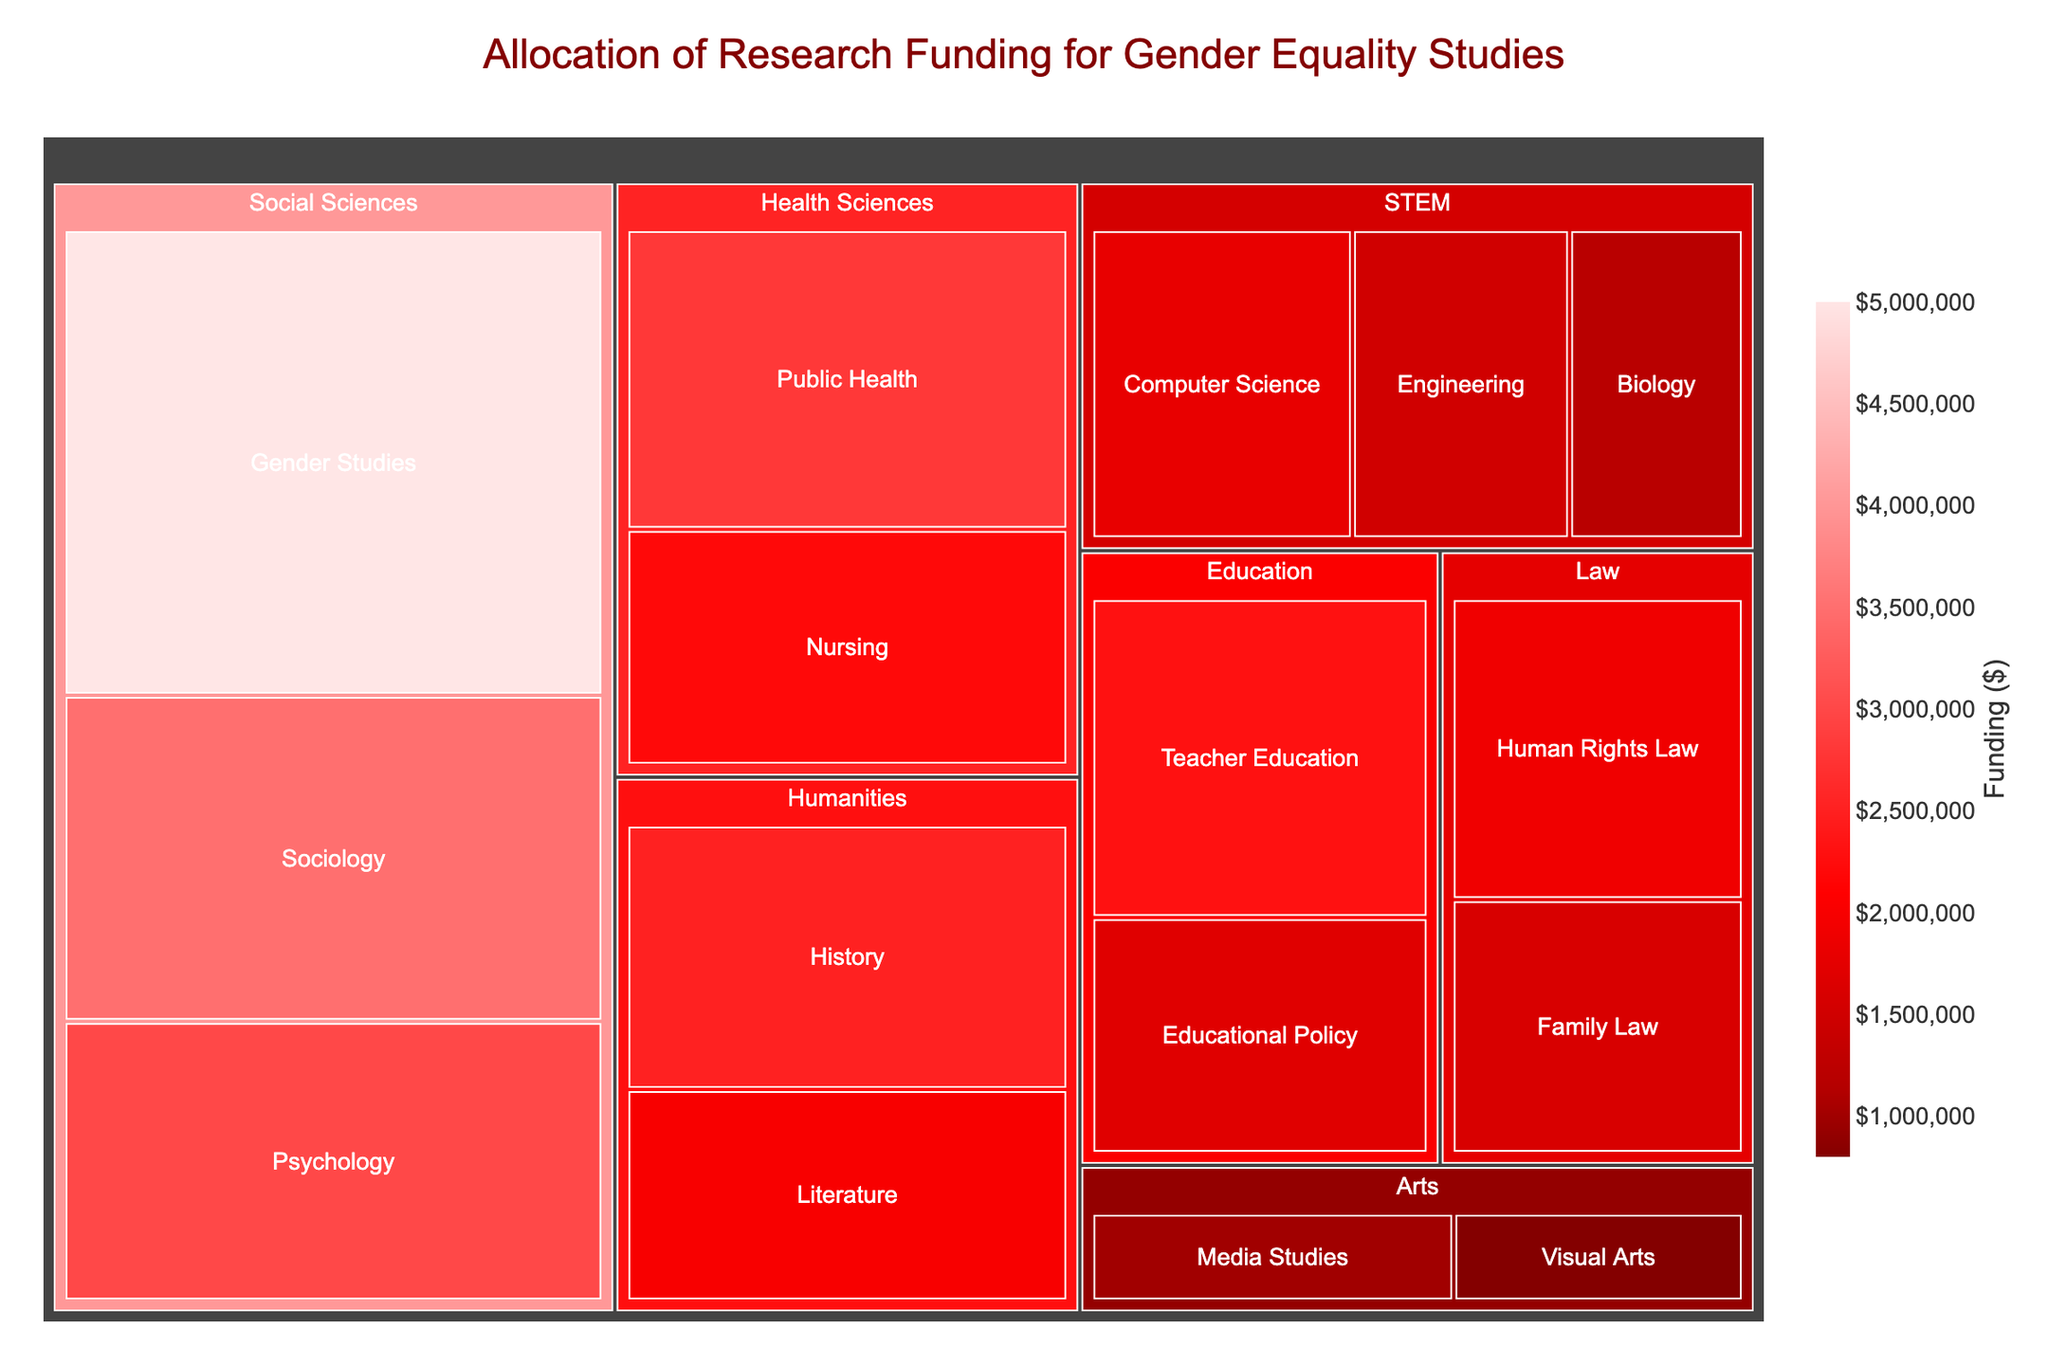what is the total funding for all social sciences subfields? The treemap shows three subfields under social sciences: gender studies, sociology, and psychology. By summing their funding amounts ($5,000,000 + $3,500,000 + $3,000,000), the total funding for social sciences is calculated.
Answer: $11,500,000 which subfield in the STEM field receives the least funding? By inspecting the treemap, it's noticeable that biology in STEM has the lowest funding among the listed subfields with $1,200,000.
Answer: Biology how does the funding for nursing compare to that for public health? Looking at the health sciences section in the treemap, nursing has $2,200,000 while public health has $2,800,000. Therefore, public health receives $600,000 more in funding compared to nursing.
Answer: Public health gets $600,000 more what is the average funding across all subfields in the Humanities field? The humanities field has two subfields: history ($2,500,000) and literature ($2,000,000). The average funding is calculated by summing these amounts ($2,500,000 + $2,000,000), which equals $4,500,000, and then dividing by 2 (the number of subfields).
Answer: $2,250,000 how does the total funding for law compare to that for education? By examining the treemap, you see the funding for law through its subfields (human rights law $1,900,000 and family law $1,600,000) summed up is $3,500,000. For education (teacher education $2,300,000 and educational policy $1,700,000), the total is $4,000,000. Thus, education receives $500,000 more compared to law.
Answer: Education gets $500,000 more which subfield overall receives the highest funding? The highest funded subfield on the treemap is gender studies in the social sciences field with a funding amount of $5,000,000.
Answer: Gender studies what percentage of the total funding is allocated to the health sciences field? Total funding for health sciences is $2,800,000 (public health) + $2,200,000 (nursing) = $5,000,000. By summing all subfields' funding, the overall total is $32,200,000. Using the formula (total health sciences funding / total funding) * 100 = (5,000,000 / 32,200,000) * 100, the result is approximately 15.53%.
Answer: Approximately 15.53% compare the funding for media studies in arts with sociology in social sciences. From the treemap, media studies in arts has $1,000,000 in funding, while sociology in social sciences has $3,500,000. Media studies receives $2,500,000 less than sociology.
Answer: Media studies receives $2,500,000 less if the funding for engineering increased by 50%, what would be the new value? The current funding for engineering is $1,500,000. An increase by 50% is calculated as $1,500,000 * 0.50 = $750,000. Adding this to the original funding gives $1,500,000 + $750,000.
Answer: $2,250,000 